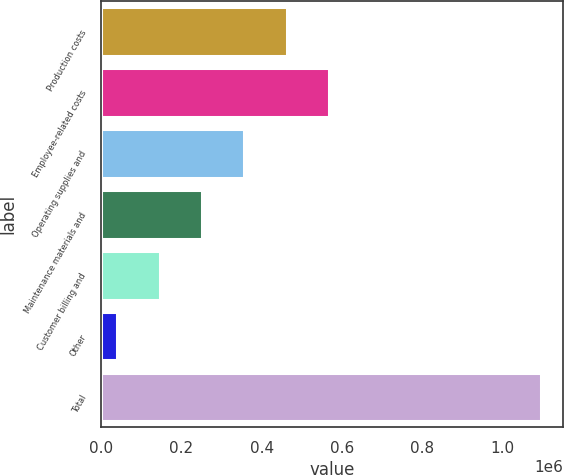Convert chart. <chart><loc_0><loc_0><loc_500><loc_500><bar_chart><fcel>Production costs<fcel>Employee-related costs<fcel>Operating supplies and<fcel>Maintenance materials and<fcel>Customer billing and<fcel>Other<fcel>Total<nl><fcel>462045<fcel>567612<fcel>356478<fcel>250912<fcel>145345<fcel>39778<fcel>1.09545e+06<nl></chart> 